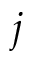<formula> <loc_0><loc_0><loc_500><loc_500>j</formula> 